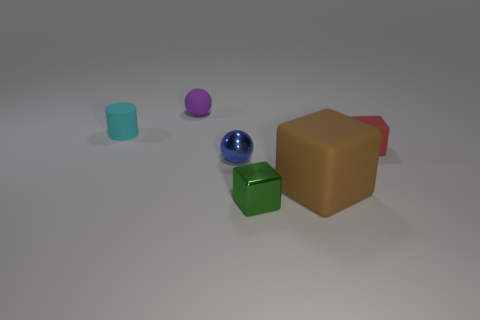How many objects are there in the image, and can you describe their colors and shapes? There are five objects in the image. From left to right, there is a small cyan cylinder, a small purple sphere, a big brown cube with a red incline on one side, a metallic blue sphere, and a smaller green cube. 